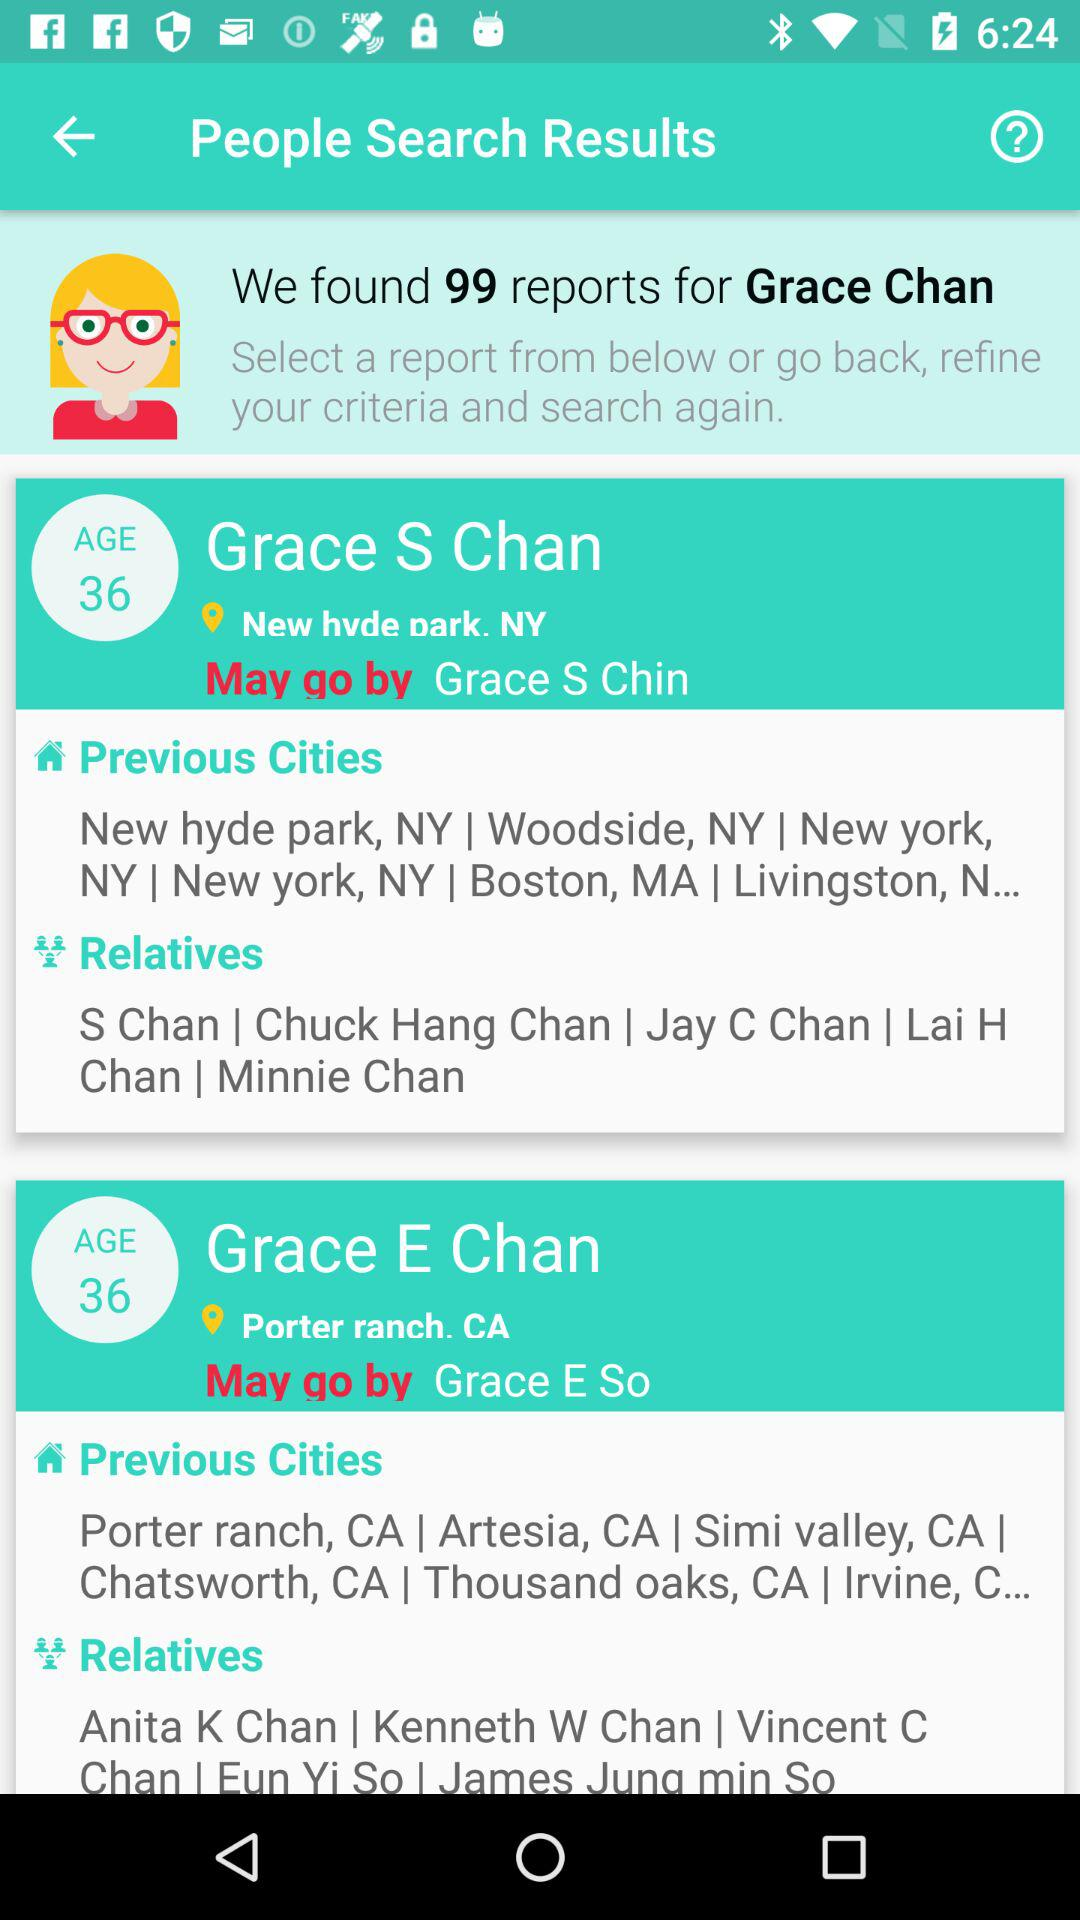Where does Chuck Hang Chan live?
When the provided information is insufficient, respond with <no answer>. <no answer> 